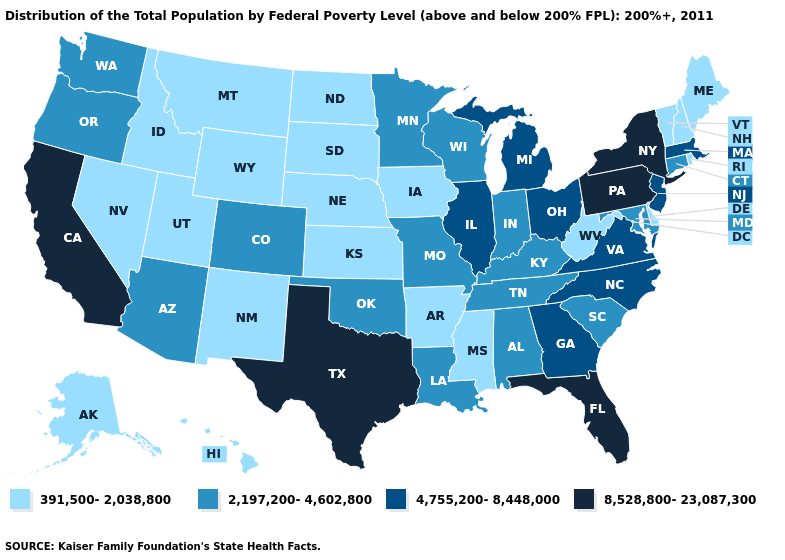Does Wyoming have a higher value than Arkansas?
Answer briefly. No. Among the states that border Nevada , which have the highest value?
Short answer required. California. Which states have the lowest value in the USA?
Quick response, please. Alaska, Arkansas, Delaware, Hawaii, Idaho, Iowa, Kansas, Maine, Mississippi, Montana, Nebraska, Nevada, New Hampshire, New Mexico, North Dakota, Rhode Island, South Dakota, Utah, Vermont, West Virginia, Wyoming. Name the states that have a value in the range 4,755,200-8,448,000?
Give a very brief answer. Georgia, Illinois, Massachusetts, Michigan, New Jersey, North Carolina, Ohio, Virginia. Among the states that border Missouri , which have the highest value?
Keep it brief. Illinois. Which states hav the highest value in the MidWest?
Concise answer only. Illinois, Michigan, Ohio. What is the value of Wisconsin?
Write a very short answer. 2,197,200-4,602,800. What is the highest value in the Northeast ?
Concise answer only. 8,528,800-23,087,300. Does the first symbol in the legend represent the smallest category?
Quick response, please. Yes. Name the states that have a value in the range 4,755,200-8,448,000?
Quick response, please. Georgia, Illinois, Massachusetts, Michigan, New Jersey, North Carolina, Ohio, Virginia. What is the highest value in the MidWest ?
Write a very short answer. 4,755,200-8,448,000. Among the states that border Missouri , does Illinois have the highest value?
Keep it brief. Yes. Name the states that have a value in the range 2,197,200-4,602,800?
Concise answer only. Alabama, Arizona, Colorado, Connecticut, Indiana, Kentucky, Louisiana, Maryland, Minnesota, Missouri, Oklahoma, Oregon, South Carolina, Tennessee, Washington, Wisconsin. What is the value of Kentucky?
Quick response, please. 2,197,200-4,602,800. Among the states that border South Dakota , which have the lowest value?
Quick response, please. Iowa, Montana, Nebraska, North Dakota, Wyoming. 